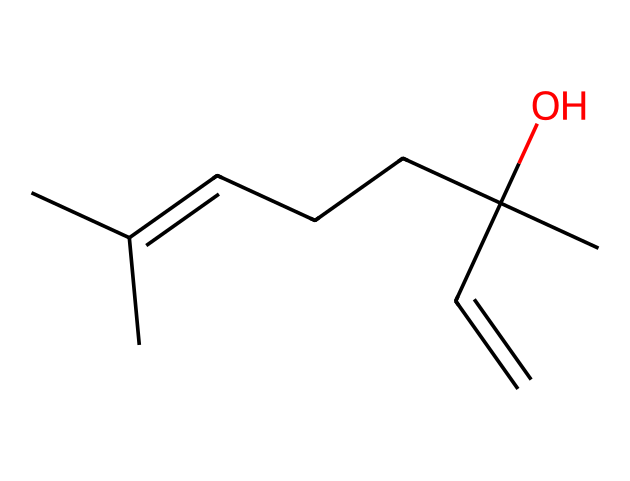What is the main functional group present in linalool? The structure shows a hydroxyl group (OH) attached to a carbon atom. This is indicative of alcohols, which is the main functional group in linalool.
Answer: alcohol How many carbon atoms are in linalool? By counting the visible carbon atoms in the structure, there are ten carbon atoms present in linalool.
Answer: ten What type of compound is linalool classified as? The structure is comprised mainly of carbon and hydrogen, with the presence of a hydroxyl group, classifying it as a terpene.
Answer: terpene What kind of bonding does linalool predominantly have? Observing the structure, linalool shows mainly single bonds between the carbon atoms, with a double bond indicated by the alkene part of the structure.
Answer: single and double bonds What is the total number of hydrogen atoms in linalool? By applying the general formula for hydrocarbons, and considering saturation, linalool has twenty hydrogen atoms combining from the carbons and the functional group.
Answer: twenty Which part of linalool contributes to its aromatic scent? The double bond and the branching structure in the carbon chain are typical of many fragrant compounds, including linalool which is known for its pleasant scent.
Answer: double bond and branching structure Is linalool naturally occurring or synthetic? Linalool is primarily derived from natural sources like lavender and other plants, making it a naturally occurring compound.
Answer: naturally occurring 